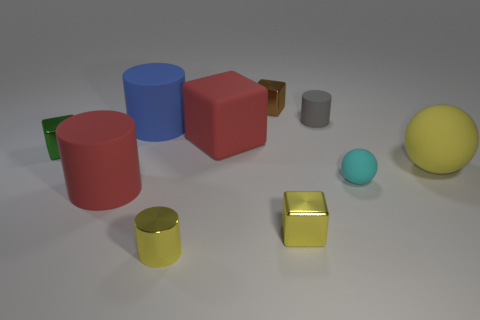Subtract 1 cylinders. How many cylinders are left? 3 Subtract all blocks. How many objects are left? 6 Subtract 1 cyan balls. How many objects are left? 9 Subtract all small brown things. Subtract all big brown metal things. How many objects are left? 9 Add 5 tiny matte cylinders. How many tiny matte cylinders are left? 6 Add 10 purple matte spheres. How many purple matte spheres exist? 10 